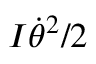Convert formula to latex. <formula><loc_0><loc_0><loc_500><loc_500>I \dot { \theta } ^ { 2 } / 2</formula> 